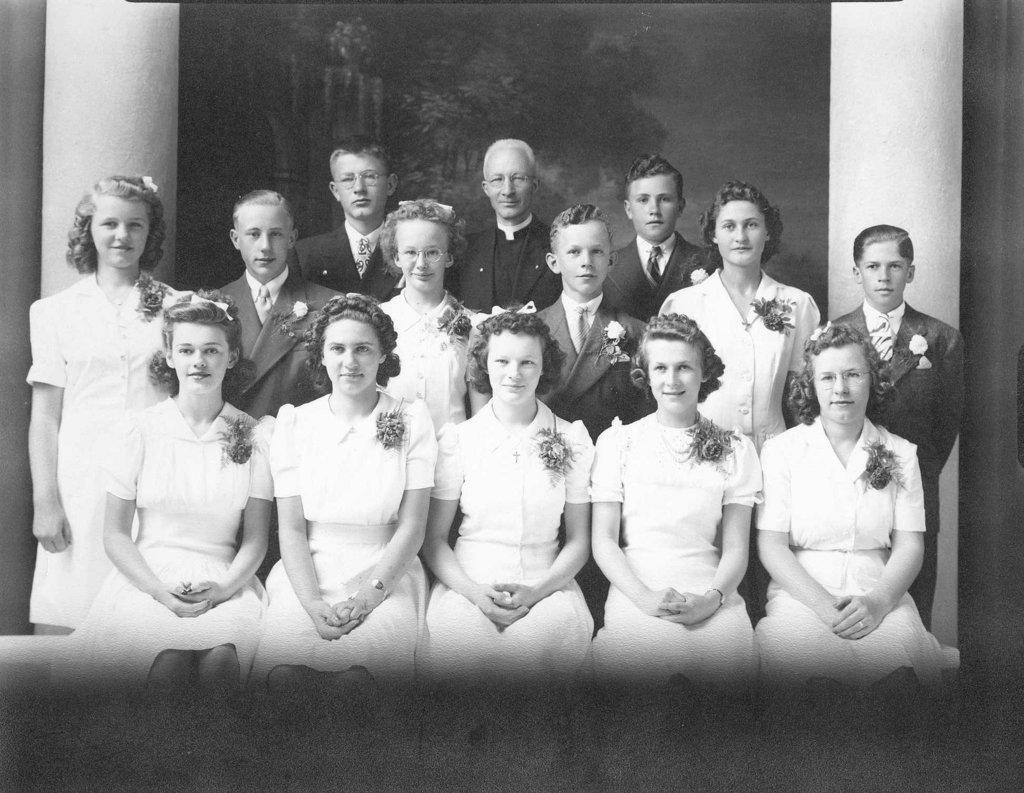How would you summarize this image in a sentence or two? In the foreground of this image, there are few persons sitting and standing and giving pose to the camera. In the background, there is a scenery wall and two pillars. 